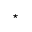Convert formula to latex. <formula><loc_0><loc_0><loc_500><loc_500>^ { * }</formula> 